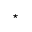Convert formula to latex. <formula><loc_0><loc_0><loc_500><loc_500>^ { * }</formula> 